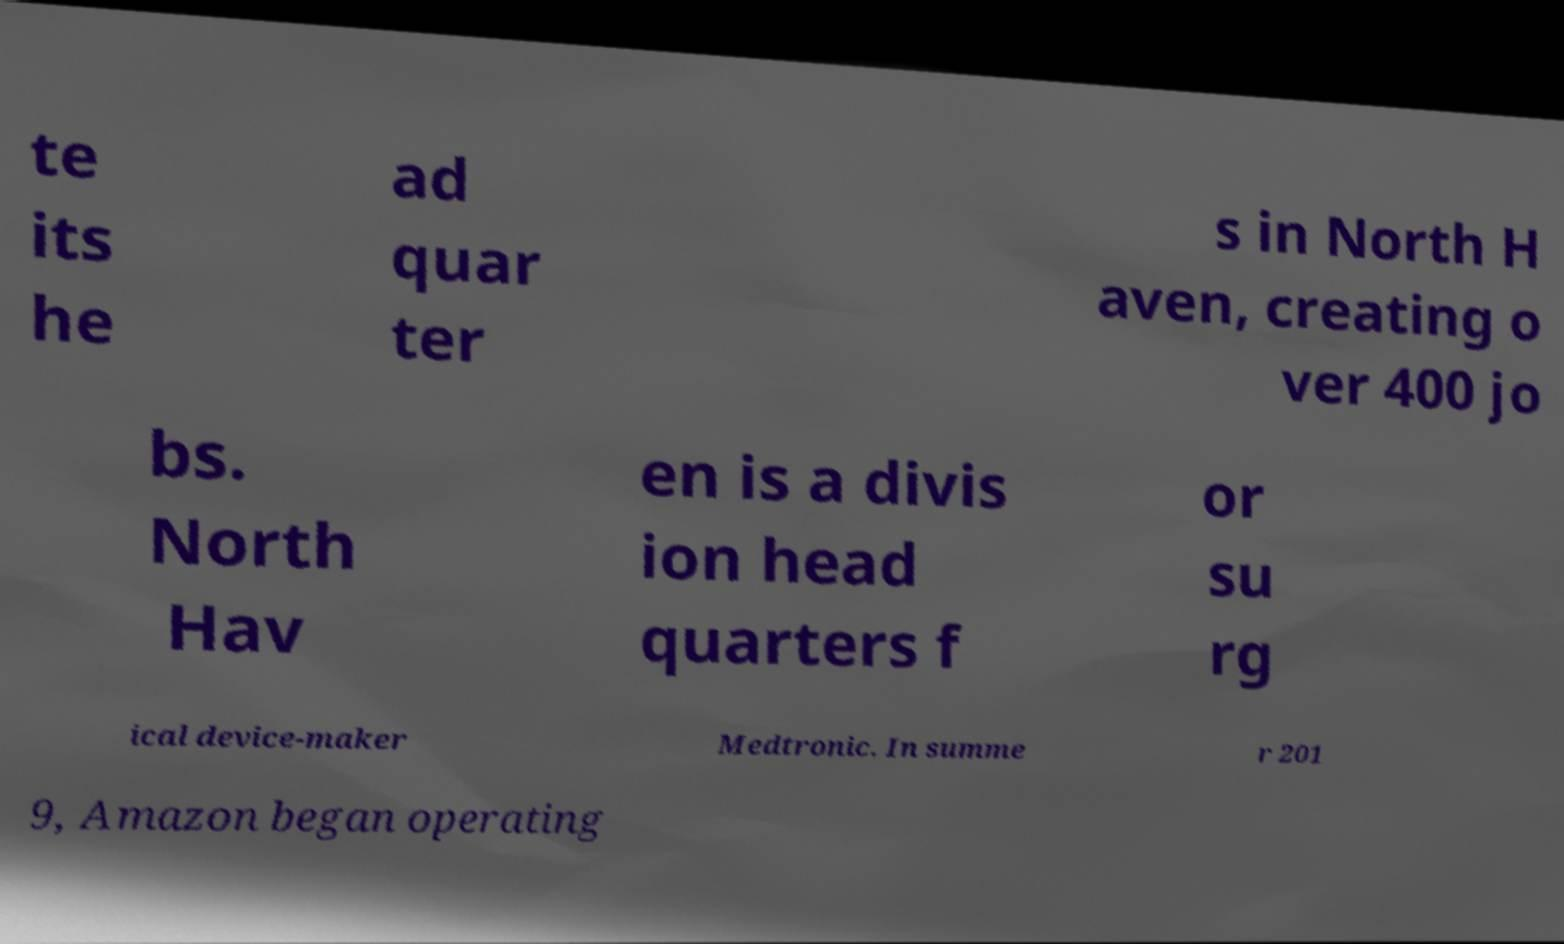For documentation purposes, I need the text within this image transcribed. Could you provide that? te its he ad quar ter s in North H aven, creating o ver 400 jo bs. North Hav en is a divis ion head quarters f or su rg ical device-maker Medtronic. In summe r 201 9, Amazon began operating 